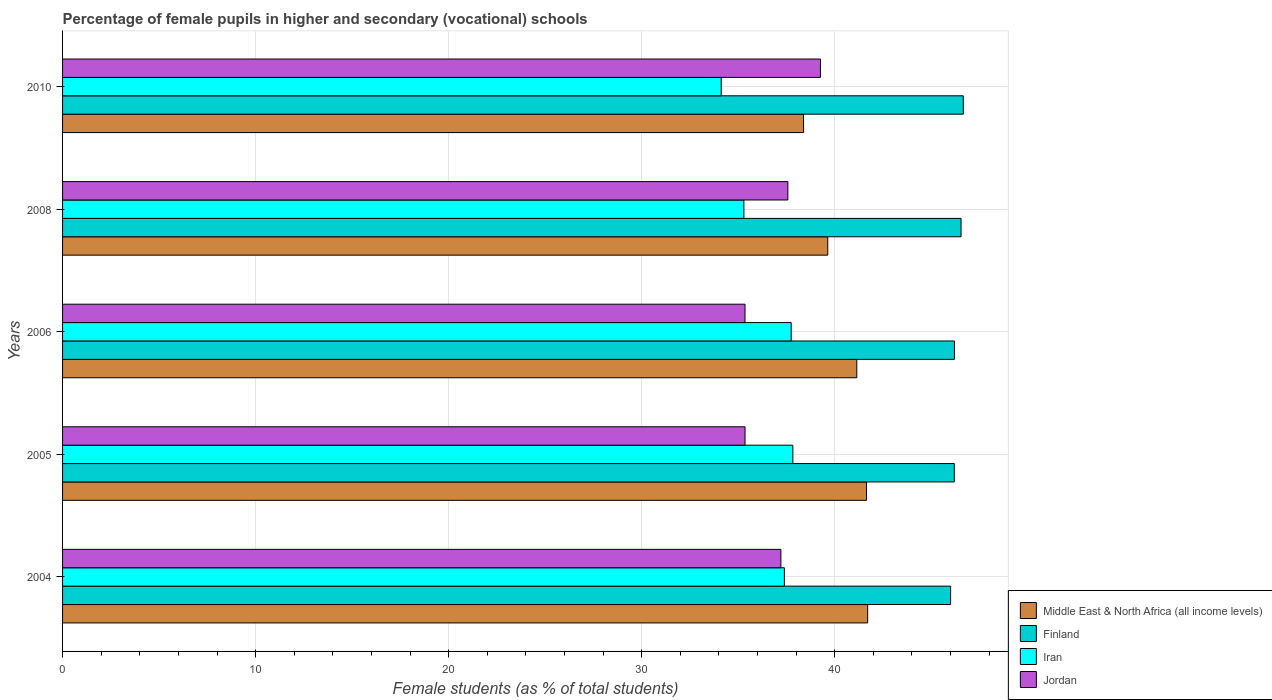How many different coloured bars are there?
Your response must be concise. 4. Are the number of bars per tick equal to the number of legend labels?
Ensure brevity in your answer.  Yes. Are the number of bars on each tick of the Y-axis equal?
Give a very brief answer. Yes. How many bars are there on the 5th tick from the top?
Your answer should be compact. 4. How many bars are there on the 4th tick from the bottom?
Ensure brevity in your answer.  4. In how many cases, is the number of bars for a given year not equal to the number of legend labels?
Make the answer very short. 0. What is the percentage of female pupils in higher and secondary schools in Iran in 2008?
Your answer should be compact. 35.3. Across all years, what is the maximum percentage of female pupils in higher and secondary schools in Finland?
Your answer should be compact. 46.66. Across all years, what is the minimum percentage of female pupils in higher and secondary schools in Middle East & North Africa (all income levels)?
Your answer should be very brief. 38.39. In which year was the percentage of female pupils in higher and secondary schools in Finland maximum?
Ensure brevity in your answer.  2010. What is the total percentage of female pupils in higher and secondary schools in Iran in the graph?
Your answer should be very brief. 182.39. What is the difference between the percentage of female pupils in higher and secondary schools in Iran in 2004 and that in 2006?
Give a very brief answer. -0.35. What is the difference between the percentage of female pupils in higher and secondary schools in Middle East & North Africa (all income levels) in 2005 and the percentage of female pupils in higher and secondary schools in Iran in 2008?
Your response must be concise. 6.35. What is the average percentage of female pupils in higher and secondary schools in Middle East & North Africa (all income levels) per year?
Your answer should be compact. 40.51. In the year 2008, what is the difference between the percentage of female pupils in higher and secondary schools in Iran and percentage of female pupils in higher and secondary schools in Jordan?
Ensure brevity in your answer.  -2.28. In how many years, is the percentage of female pupils in higher and secondary schools in Middle East & North Africa (all income levels) greater than 42 %?
Ensure brevity in your answer.  0. What is the ratio of the percentage of female pupils in higher and secondary schools in Middle East & North Africa (all income levels) in 2004 to that in 2008?
Your response must be concise. 1.05. Is the percentage of female pupils in higher and secondary schools in Jordan in 2005 less than that in 2006?
Offer a terse response. No. What is the difference between the highest and the second highest percentage of female pupils in higher and secondary schools in Jordan?
Ensure brevity in your answer.  1.69. What is the difference between the highest and the lowest percentage of female pupils in higher and secondary schools in Iran?
Provide a short and direct response. 3.71. Is it the case that in every year, the sum of the percentage of female pupils in higher and secondary schools in Middle East & North Africa (all income levels) and percentage of female pupils in higher and secondary schools in Jordan is greater than the sum of percentage of female pupils in higher and secondary schools in Iran and percentage of female pupils in higher and secondary schools in Finland?
Offer a very short reply. Yes. What does the 1st bar from the top in 2008 represents?
Ensure brevity in your answer.  Jordan. What does the 1st bar from the bottom in 2008 represents?
Your response must be concise. Middle East & North Africa (all income levels). Is it the case that in every year, the sum of the percentage of female pupils in higher and secondary schools in Finland and percentage of female pupils in higher and secondary schools in Iran is greater than the percentage of female pupils in higher and secondary schools in Jordan?
Keep it short and to the point. Yes. How many bars are there?
Ensure brevity in your answer.  20. Are all the bars in the graph horizontal?
Offer a terse response. Yes. Are the values on the major ticks of X-axis written in scientific E-notation?
Your answer should be very brief. No. Does the graph contain any zero values?
Your answer should be very brief. No. Does the graph contain grids?
Provide a succinct answer. Yes. What is the title of the graph?
Your answer should be very brief. Percentage of female pupils in higher and secondary (vocational) schools. What is the label or title of the X-axis?
Your response must be concise. Female students (as % of total students). What is the label or title of the Y-axis?
Make the answer very short. Years. What is the Female students (as % of total students) in Middle East & North Africa (all income levels) in 2004?
Your answer should be compact. 41.71. What is the Female students (as % of total students) of Finland in 2004?
Your response must be concise. 46. What is the Female students (as % of total students) of Iran in 2004?
Offer a terse response. 37.39. What is the Female students (as % of total students) in Jordan in 2004?
Make the answer very short. 37.21. What is the Female students (as % of total students) in Middle East & North Africa (all income levels) in 2005?
Provide a succinct answer. 41.65. What is the Female students (as % of total students) in Finland in 2005?
Your answer should be compact. 46.2. What is the Female students (as % of total students) of Iran in 2005?
Make the answer very short. 37.83. What is the Female students (as % of total students) in Jordan in 2005?
Provide a succinct answer. 35.35. What is the Female students (as % of total students) of Middle East & North Africa (all income levels) in 2006?
Provide a short and direct response. 41.14. What is the Female students (as % of total students) of Finland in 2006?
Your answer should be very brief. 46.2. What is the Female students (as % of total students) of Iran in 2006?
Provide a short and direct response. 37.75. What is the Female students (as % of total students) of Jordan in 2006?
Your response must be concise. 35.35. What is the Female students (as % of total students) of Middle East & North Africa (all income levels) in 2008?
Ensure brevity in your answer.  39.64. What is the Female students (as % of total students) in Finland in 2008?
Make the answer very short. 46.54. What is the Female students (as % of total students) of Iran in 2008?
Provide a short and direct response. 35.3. What is the Female students (as % of total students) in Jordan in 2008?
Your response must be concise. 37.57. What is the Female students (as % of total students) in Middle East & North Africa (all income levels) in 2010?
Your answer should be compact. 38.39. What is the Female students (as % of total students) of Finland in 2010?
Keep it short and to the point. 46.66. What is the Female students (as % of total students) of Iran in 2010?
Make the answer very short. 34.12. What is the Female students (as % of total students) in Jordan in 2010?
Your answer should be very brief. 39.26. Across all years, what is the maximum Female students (as % of total students) of Middle East & North Africa (all income levels)?
Your response must be concise. 41.71. Across all years, what is the maximum Female students (as % of total students) in Finland?
Provide a succinct answer. 46.66. Across all years, what is the maximum Female students (as % of total students) in Iran?
Give a very brief answer. 37.83. Across all years, what is the maximum Female students (as % of total students) in Jordan?
Keep it short and to the point. 39.26. Across all years, what is the minimum Female students (as % of total students) in Middle East & North Africa (all income levels)?
Make the answer very short. 38.39. Across all years, what is the minimum Female students (as % of total students) of Finland?
Give a very brief answer. 46. Across all years, what is the minimum Female students (as % of total students) of Iran?
Make the answer very short. 34.12. Across all years, what is the minimum Female students (as % of total students) of Jordan?
Offer a very short reply. 35.35. What is the total Female students (as % of total students) of Middle East & North Africa (all income levels) in the graph?
Your response must be concise. 202.53. What is the total Female students (as % of total students) of Finland in the graph?
Your response must be concise. 231.61. What is the total Female students (as % of total students) of Iran in the graph?
Your answer should be very brief. 182.39. What is the total Female students (as % of total students) of Jordan in the graph?
Give a very brief answer. 184.76. What is the difference between the Female students (as % of total students) in Middle East & North Africa (all income levels) in 2004 and that in 2005?
Your response must be concise. 0.06. What is the difference between the Female students (as % of total students) in Finland in 2004 and that in 2005?
Ensure brevity in your answer.  -0.19. What is the difference between the Female students (as % of total students) of Iran in 2004 and that in 2005?
Provide a short and direct response. -0.44. What is the difference between the Female students (as % of total students) of Jordan in 2004 and that in 2005?
Your answer should be compact. 1.86. What is the difference between the Female students (as % of total students) of Middle East & North Africa (all income levels) in 2004 and that in 2006?
Give a very brief answer. 0.56. What is the difference between the Female students (as % of total students) of Finland in 2004 and that in 2006?
Ensure brevity in your answer.  -0.2. What is the difference between the Female students (as % of total students) of Iran in 2004 and that in 2006?
Your answer should be very brief. -0.35. What is the difference between the Female students (as % of total students) in Jordan in 2004 and that in 2006?
Provide a short and direct response. 1.86. What is the difference between the Female students (as % of total students) in Middle East & North Africa (all income levels) in 2004 and that in 2008?
Your answer should be very brief. 2.07. What is the difference between the Female students (as % of total students) in Finland in 2004 and that in 2008?
Your answer should be very brief. -0.54. What is the difference between the Female students (as % of total students) in Iran in 2004 and that in 2008?
Provide a short and direct response. 2.1. What is the difference between the Female students (as % of total students) in Jordan in 2004 and that in 2008?
Offer a very short reply. -0.36. What is the difference between the Female students (as % of total students) of Middle East & North Africa (all income levels) in 2004 and that in 2010?
Offer a terse response. 3.32. What is the difference between the Female students (as % of total students) in Finland in 2004 and that in 2010?
Provide a succinct answer. -0.66. What is the difference between the Female students (as % of total students) of Iran in 2004 and that in 2010?
Your answer should be compact. 3.27. What is the difference between the Female students (as % of total students) in Jordan in 2004 and that in 2010?
Your answer should be compact. -2.05. What is the difference between the Female students (as % of total students) of Middle East & North Africa (all income levels) in 2005 and that in 2006?
Your response must be concise. 0.5. What is the difference between the Female students (as % of total students) of Finland in 2005 and that in 2006?
Your answer should be very brief. -0.01. What is the difference between the Female students (as % of total students) of Iran in 2005 and that in 2006?
Your answer should be compact. 0.09. What is the difference between the Female students (as % of total students) in Jordan in 2005 and that in 2006?
Give a very brief answer. 0. What is the difference between the Female students (as % of total students) in Middle East & North Africa (all income levels) in 2005 and that in 2008?
Keep it short and to the point. 2.01. What is the difference between the Female students (as % of total students) of Finland in 2005 and that in 2008?
Your answer should be compact. -0.35. What is the difference between the Female students (as % of total students) in Iran in 2005 and that in 2008?
Keep it short and to the point. 2.54. What is the difference between the Female students (as % of total students) of Jordan in 2005 and that in 2008?
Offer a terse response. -2.22. What is the difference between the Female students (as % of total students) in Middle East & North Africa (all income levels) in 2005 and that in 2010?
Keep it short and to the point. 3.26. What is the difference between the Female students (as % of total students) of Finland in 2005 and that in 2010?
Keep it short and to the point. -0.47. What is the difference between the Female students (as % of total students) in Iran in 2005 and that in 2010?
Give a very brief answer. 3.71. What is the difference between the Female students (as % of total students) of Jordan in 2005 and that in 2010?
Offer a terse response. -3.91. What is the difference between the Female students (as % of total students) of Middle East & North Africa (all income levels) in 2006 and that in 2008?
Your answer should be compact. 1.5. What is the difference between the Female students (as % of total students) in Finland in 2006 and that in 2008?
Your answer should be compact. -0.34. What is the difference between the Female students (as % of total students) in Iran in 2006 and that in 2008?
Keep it short and to the point. 2.45. What is the difference between the Female students (as % of total students) of Jordan in 2006 and that in 2008?
Your answer should be compact. -2.22. What is the difference between the Female students (as % of total students) in Middle East & North Africa (all income levels) in 2006 and that in 2010?
Your answer should be compact. 2.76. What is the difference between the Female students (as % of total students) in Finland in 2006 and that in 2010?
Give a very brief answer. -0.46. What is the difference between the Female students (as % of total students) in Iran in 2006 and that in 2010?
Your answer should be very brief. 3.63. What is the difference between the Female students (as % of total students) in Jordan in 2006 and that in 2010?
Give a very brief answer. -3.91. What is the difference between the Female students (as % of total students) of Middle East & North Africa (all income levels) in 2008 and that in 2010?
Offer a very short reply. 1.26. What is the difference between the Female students (as % of total students) in Finland in 2008 and that in 2010?
Your answer should be very brief. -0.12. What is the difference between the Female students (as % of total students) in Iran in 2008 and that in 2010?
Give a very brief answer. 1.17. What is the difference between the Female students (as % of total students) of Jordan in 2008 and that in 2010?
Offer a very short reply. -1.69. What is the difference between the Female students (as % of total students) of Middle East & North Africa (all income levels) in 2004 and the Female students (as % of total students) of Finland in 2005?
Provide a short and direct response. -4.49. What is the difference between the Female students (as % of total students) of Middle East & North Africa (all income levels) in 2004 and the Female students (as % of total students) of Iran in 2005?
Your answer should be very brief. 3.88. What is the difference between the Female students (as % of total students) in Middle East & North Africa (all income levels) in 2004 and the Female students (as % of total students) in Jordan in 2005?
Offer a very short reply. 6.35. What is the difference between the Female students (as % of total students) of Finland in 2004 and the Female students (as % of total students) of Iran in 2005?
Make the answer very short. 8.17. What is the difference between the Female students (as % of total students) in Finland in 2004 and the Female students (as % of total students) in Jordan in 2005?
Your answer should be compact. 10.65. What is the difference between the Female students (as % of total students) of Iran in 2004 and the Female students (as % of total students) of Jordan in 2005?
Give a very brief answer. 2.04. What is the difference between the Female students (as % of total students) in Middle East & North Africa (all income levels) in 2004 and the Female students (as % of total students) in Finland in 2006?
Provide a short and direct response. -4.5. What is the difference between the Female students (as % of total students) in Middle East & North Africa (all income levels) in 2004 and the Female students (as % of total students) in Iran in 2006?
Offer a terse response. 3.96. What is the difference between the Female students (as % of total students) in Middle East & North Africa (all income levels) in 2004 and the Female students (as % of total students) in Jordan in 2006?
Your answer should be very brief. 6.35. What is the difference between the Female students (as % of total students) in Finland in 2004 and the Female students (as % of total students) in Iran in 2006?
Give a very brief answer. 8.26. What is the difference between the Female students (as % of total students) in Finland in 2004 and the Female students (as % of total students) in Jordan in 2006?
Ensure brevity in your answer.  10.65. What is the difference between the Female students (as % of total students) in Iran in 2004 and the Female students (as % of total students) in Jordan in 2006?
Ensure brevity in your answer.  2.04. What is the difference between the Female students (as % of total students) in Middle East & North Africa (all income levels) in 2004 and the Female students (as % of total students) in Finland in 2008?
Offer a very short reply. -4.84. What is the difference between the Female students (as % of total students) in Middle East & North Africa (all income levels) in 2004 and the Female students (as % of total students) in Iran in 2008?
Your response must be concise. 6.41. What is the difference between the Female students (as % of total students) of Middle East & North Africa (all income levels) in 2004 and the Female students (as % of total students) of Jordan in 2008?
Keep it short and to the point. 4.13. What is the difference between the Female students (as % of total students) in Finland in 2004 and the Female students (as % of total students) in Iran in 2008?
Give a very brief answer. 10.71. What is the difference between the Female students (as % of total students) in Finland in 2004 and the Female students (as % of total students) in Jordan in 2008?
Make the answer very short. 8.43. What is the difference between the Female students (as % of total students) of Iran in 2004 and the Female students (as % of total students) of Jordan in 2008?
Your answer should be compact. -0.18. What is the difference between the Female students (as % of total students) of Middle East & North Africa (all income levels) in 2004 and the Female students (as % of total students) of Finland in 2010?
Provide a succinct answer. -4.95. What is the difference between the Female students (as % of total students) of Middle East & North Africa (all income levels) in 2004 and the Female students (as % of total students) of Iran in 2010?
Your answer should be compact. 7.59. What is the difference between the Female students (as % of total students) in Middle East & North Africa (all income levels) in 2004 and the Female students (as % of total students) in Jordan in 2010?
Offer a very short reply. 2.45. What is the difference between the Female students (as % of total students) in Finland in 2004 and the Female students (as % of total students) in Iran in 2010?
Keep it short and to the point. 11.88. What is the difference between the Female students (as % of total students) of Finland in 2004 and the Female students (as % of total students) of Jordan in 2010?
Provide a short and direct response. 6.74. What is the difference between the Female students (as % of total students) of Iran in 2004 and the Female students (as % of total students) of Jordan in 2010?
Offer a terse response. -1.87. What is the difference between the Female students (as % of total students) in Middle East & North Africa (all income levels) in 2005 and the Female students (as % of total students) in Finland in 2006?
Make the answer very short. -4.56. What is the difference between the Female students (as % of total students) of Middle East & North Africa (all income levels) in 2005 and the Female students (as % of total students) of Iran in 2006?
Provide a short and direct response. 3.9. What is the difference between the Female students (as % of total students) in Middle East & North Africa (all income levels) in 2005 and the Female students (as % of total students) in Jordan in 2006?
Offer a terse response. 6.29. What is the difference between the Female students (as % of total students) in Finland in 2005 and the Female students (as % of total students) in Iran in 2006?
Ensure brevity in your answer.  8.45. What is the difference between the Female students (as % of total students) of Finland in 2005 and the Female students (as % of total students) of Jordan in 2006?
Offer a terse response. 10.84. What is the difference between the Female students (as % of total students) in Iran in 2005 and the Female students (as % of total students) in Jordan in 2006?
Provide a short and direct response. 2.48. What is the difference between the Female students (as % of total students) in Middle East & North Africa (all income levels) in 2005 and the Female students (as % of total students) in Finland in 2008?
Provide a succinct answer. -4.9. What is the difference between the Female students (as % of total students) of Middle East & North Africa (all income levels) in 2005 and the Female students (as % of total students) of Iran in 2008?
Offer a terse response. 6.35. What is the difference between the Female students (as % of total students) of Middle East & North Africa (all income levels) in 2005 and the Female students (as % of total students) of Jordan in 2008?
Provide a short and direct response. 4.07. What is the difference between the Female students (as % of total students) of Finland in 2005 and the Female students (as % of total students) of Iran in 2008?
Your answer should be very brief. 10.9. What is the difference between the Female students (as % of total students) in Finland in 2005 and the Female students (as % of total students) in Jordan in 2008?
Keep it short and to the point. 8.62. What is the difference between the Female students (as % of total students) in Iran in 2005 and the Female students (as % of total students) in Jordan in 2008?
Make the answer very short. 0.26. What is the difference between the Female students (as % of total students) of Middle East & North Africa (all income levels) in 2005 and the Female students (as % of total students) of Finland in 2010?
Your answer should be very brief. -5.02. What is the difference between the Female students (as % of total students) in Middle East & North Africa (all income levels) in 2005 and the Female students (as % of total students) in Iran in 2010?
Your answer should be compact. 7.53. What is the difference between the Female students (as % of total students) of Middle East & North Africa (all income levels) in 2005 and the Female students (as % of total students) of Jordan in 2010?
Your answer should be very brief. 2.39. What is the difference between the Female students (as % of total students) in Finland in 2005 and the Female students (as % of total students) in Iran in 2010?
Keep it short and to the point. 12.07. What is the difference between the Female students (as % of total students) in Finland in 2005 and the Female students (as % of total students) in Jordan in 2010?
Offer a very short reply. 6.93. What is the difference between the Female students (as % of total students) of Iran in 2005 and the Female students (as % of total students) of Jordan in 2010?
Offer a very short reply. -1.43. What is the difference between the Female students (as % of total students) of Middle East & North Africa (all income levels) in 2006 and the Female students (as % of total students) of Finland in 2008?
Give a very brief answer. -5.4. What is the difference between the Female students (as % of total students) in Middle East & North Africa (all income levels) in 2006 and the Female students (as % of total students) in Iran in 2008?
Offer a terse response. 5.85. What is the difference between the Female students (as % of total students) of Middle East & North Africa (all income levels) in 2006 and the Female students (as % of total students) of Jordan in 2008?
Offer a terse response. 3.57. What is the difference between the Female students (as % of total students) of Finland in 2006 and the Female students (as % of total students) of Iran in 2008?
Give a very brief answer. 10.91. What is the difference between the Female students (as % of total students) in Finland in 2006 and the Female students (as % of total students) in Jordan in 2008?
Your answer should be very brief. 8.63. What is the difference between the Female students (as % of total students) in Iran in 2006 and the Female students (as % of total students) in Jordan in 2008?
Ensure brevity in your answer.  0.17. What is the difference between the Female students (as % of total students) in Middle East & North Africa (all income levels) in 2006 and the Female students (as % of total students) in Finland in 2010?
Your answer should be very brief. -5.52. What is the difference between the Female students (as % of total students) of Middle East & North Africa (all income levels) in 2006 and the Female students (as % of total students) of Iran in 2010?
Provide a short and direct response. 7.02. What is the difference between the Female students (as % of total students) of Middle East & North Africa (all income levels) in 2006 and the Female students (as % of total students) of Jordan in 2010?
Offer a terse response. 1.88. What is the difference between the Female students (as % of total students) in Finland in 2006 and the Female students (as % of total students) in Iran in 2010?
Ensure brevity in your answer.  12.08. What is the difference between the Female students (as % of total students) in Finland in 2006 and the Female students (as % of total students) in Jordan in 2010?
Keep it short and to the point. 6.94. What is the difference between the Female students (as % of total students) in Iran in 2006 and the Female students (as % of total students) in Jordan in 2010?
Your response must be concise. -1.52. What is the difference between the Female students (as % of total students) in Middle East & North Africa (all income levels) in 2008 and the Female students (as % of total students) in Finland in 2010?
Offer a very short reply. -7.02. What is the difference between the Female students (as % of total students) in Middle East & North Africa (all income levels) in 2008 and the Female students (as % of total students) in Iran in 2010?
Offer a terse response. 5.52. What is the difference between the Female students (as % of total students) in Middle East & North Africa (all income levels) in 2008 and the Female students (as % of total students) in Jordan in 2010?
Offer a very short reply. 0.38. What is the difference between the Female students (as % of total students) of Finland in 2008 and the Female students (as % of total students) of Iran in 2010?
Keep it short and to the point. 12.42. What is the difference between the Female students (as % of total students) in Finland in 2008 and the Female students (as % of total students) in Jordan in 2010?
Provide a short and direct response. 7.28. What is the difference between the Female students (as % of total students) of Iran in 2008 and the Female students (as % of total students) of Jordan in 2010?
Offer a terse response. -3.97. What is the average Female students (as % of total students) in Middle East & North Africa (all income levels) per year?
Offer a terse response. 40.51. What is the average Female students (as % of total students) in Finland per year?
Your response must be concise. 46.32. What is the average Female students (as % of total students) in Iran per year?
Make the answer very short. 36.48. What is the average Female students (as % of total students) of Jordan per year?
Offer a terse response. 36.95. In the year 2004, what is the difference between the Female students (as % of total students) in Middle East & North Africa (all income levels) and Female students (as % of total students) in Finland?
Make the answer very short. -4.3. In the year 2004, what is the difference between the Female students (as % of total students) of Middle East & North Africa (all income levels) and Female students (as % of total students) of Iran?
Your response must be concise. 4.31. In the year 2004, what is the difference between the Female students (as % of total students) of Middle East & North Africa (all income levels) and Female students (as % of total students) of Jordan?
Your answer should be very brief. 4.5. In the year 2004, what is the difference between the Female students (as % of total students) in Finland and Female students (as % of total students) in Iran?
Offer a terse response. 8.61. In the year 2004, what is the difference between the Female students (as % of total students) in Finland and Female students (as % of total students) in Jordan?
Your answer should be compact. 8.79. In the year 2004, what is the difference between the Female students (as % of total students) of Iran and Female students (as % of total students) of Jordan?
Provide a short and direct response. 0.18. In the year 2005, what is the difference between the Female students (as % of total students) of Middle East & North Africa (all income levels) and Female students (as % of total students) of Finland?
Make the answer very short. -4.55. In the year 2005, what is the difference between the Female students (as % of total students) in Middle East & North Africa (all income levels) and Female students (as % of total students) in Iran?
Your answer should be very brief. 3.82. In the year 2005, what is the difference between the Female students (as % of total students) in Middle East & North Africa (all income levels) and Female students (as % of total students) in Jordan?
Make the answer very short. 6.29. In the year 2005, what is the difference between the Female students (as % of total students) of Finland and Female students (as % of total students) of Iran?
Keep it short and to the point. 8.36. In the year 2005, what is the difference between the Female students (as % of total students) of Finland and Female students (as % of total students) of Jordan?
Your answer should be compact. 10.84. In the year 2005, what is the difference between the Female students (as % of total students) in Iran and Female students (as % of total students) in Jordan?
Your answer should be very brief. 2.48. In the year 2006, what is the difference between the Female students (as % of total students) of Middle East & North Africa (all income levels) and Female students (as % of total students) of Finland?
Keep it short and to the point. -5.06. In the year 2006, what is the difference between the Female students (as % of total students) of Middle East & North Africa (all income levels) and Female students (as % of total students) of Iran?
Ensure brevity in your answer.  3.4. In the year 2006, what is the difference between the Female students (as % of total students) in Middle East & North Africa (all income levels) and Female students (as % of total students) in Jordan?
Your response must be concise. 5.79. In the year 2006, what is the difference between the Female students (as % of total students) of Finland and Female students (as % of total students) of Iran?
Offer a very short reply. 8.46. In the year 2006, what is the difference between the Female students (as % of total students) of Finland and Female students (as % of total students) of Jordan?
Your answer should be very brief. 10.85. In the year 2006, what is the difference between the Female students (as % of total students) in Iran and Female students (as % of total students) in Jordan?
Your answer should be very brief. 2.39. In the year 2008, what is the difference between the Female students (as % of total students) in Middle East & North Africa (all income levels) and Female students (as % of total students) in Finland?
Your response must be concise. -6.9. In the year 2008, what is the difference between the Female students (as % of total students) of Middle East & North Africa (all income levels) and Female students (as % of total students) of Iran?
Offer a very short reply. 4.35. In the year 2008, what is the difference between the Female students (as % of total students) of Middle East & North Africa (all income levels) and Female students (as % of total students) of Jordan?
Your answer should be very brief. 2.07. In the year 2008, what is the difference between the Female students (as % of total students) of Finland and Female students (as % of total students) of Iran?
Offer a terse response. 11.25. In the year 2008, what is the difference between the Female students (as % of total students) of Finland and Female students (as % of total students) of Jordan?
Offer a terse response. 8.97. In the year 2008, what is the difference between the Female students (as % of total students) in Iran and Female students (as % of total students) in Jordan?
Offer a terse response. -2.28. In the year 2010, what is the difference between the Female students (as % of total students) of Middle East & North Africa (all income levels) and Female students (as % of total students) of Finland?
Your answer should be very brief. -8.28. In the year 2010, what is the difference between the Female students (as % of total students) of Middle East & North Africa (all income levels) and Female students (as % of total students) of Iran?
Give a very brief answer. 4.26. In the year 2010, what is the difference between the Female students (as % of total students) of Middle East & North Africa (all income levels) and Female students (as % of total students) of Jordan?
Your answer should be compact. -0.88. In the year 2010, what is the difference between the Female students (as % of total students) in Finland and Female students (as % of total students) in Iran?
Keep it short and to the point. 12.54. In the year 2010, what is the difference between the Female students (as % of total students) in Finland and Female students (as % of total students) in Jordan?
Ensure brevity in your answer.  7.4. In the year 2010, what is the difference between the Female students (as % of total students) in Iran and Female students (as % of total students) in Jordan?
Provide a short and direct response. -5.14. What is the ratio of the Female students (as % of total students) in Finland in 2004 to that in 2005?
Your response must be concise. 1. What is the ratio of the Female students (as % of total students) in Iran in 2004 to that in 2005?
Provide a short and direct response. 0.99. What is the ratio of the Female students (as % of total students) of Jordan in 2004 to that in 2005?
Make the answer very short. 1.05. What is the ratio of the Female students (as % of total students) of Middle East & North Africa (all income levels) in 2004 to that in 2006?
Your answer should be very brief. 1.01. What is the ratio of the Female students (as % of total students) in Iran in 2004 to that in 2006?
Ensure brevity in your answer.  0.99. What is the ratio of the Female students (as % of total students) of Jordan in 2004 to that in 2006?
Your answer should be compact. 1.05. What is the ratio of the Female students (as % of total students) of Middle East & North Africa (all income levels) in 2004 to that in 2008?
Offer a very short reply. 1.05. What is the ratio of the Female students (as % of total students) in Finland in 2004 to that in 2008?
Ensure brevity in your answer.  0.99. What is the ratio of the Female students (as % of total students) in Iran in 2004 to that in 2008?
Your response must be concise. 1.06. What is the ratio of the Female students (as % of total students) in Middle East & North Africa (all income levels) in 2004 to that in 2010?
Ensure brevity in your answer.  1.09. What is the ratio of the Female students (as % of total students) in Finland in 2004 to that in 2010?
Your answer should be compact. 0.99. What is the ratio of the Female students (as % of total students) in Iran in 2004 to that in 2010?
Offer a very short reply. 1.1. What is the ratio of the Female students (as % of total students) in Jordan in 2004 to that in 2010?
Provide a succinct answer. 0.95. What is the ratio of the Female students (as % of total students) in Middle East & North Africa (all income levels) in 2005 to that in 2006?
Your response must be concise. 1.01. What is the ratio of the Female students (as % of total students) in Finland in 2005 to that in 2006?
Your answer should be very brief. 1. What is the ratio of the Female students (as % of total students) in Jordan in 2005 to that in 2006?
Keep it short and to the point. 1. What is the ratio of the Female students (as % of total students) of Middle East & North Africa (all income levels) in 2005 to that in 2008?
Your answer should be very brief. 1.05. What is the ratio of the Female students (as % of total students) of Iran in 2005 to that in 2008?
Offer a terse response. 1.07. What is the ratio of the Female students (as % of total students) of Jordan in 2005 to that in 2008?
Give a very brief answer. 0.94. What is the ratio of the Female students (as % of total students) in Middle East & North Africa (all income levels) in 2005 to that in 2010?
Give a very brief answer. 1.08. What is the ratio of the Female students (as % of total students) in Iran in 2005 to that in 2010?
Your answer should be compact. 1.11. What is the ratio of the Female students (as % of total students) of Jordan in 2005 to that in 2010?
Your answer should be compact. 0.9. What is the ratio of the Female students (as % of total students) of Middle East & North Africa (all income levels) in 2006 to that in 2008?
Your answer should be compact. 1.04. What is the ratio of the Female students (as % of total students) of Iran in 2006 to that in 2008?
Keep it short and to the point. 1.07. What is the ratio of the Female students (as % of total students) of Jordan in 2006 to that in 2008?
Keep it short and to the point. 0.94. What is the ratio of the Female students (as % of total students) in Middle East & North Africa (all income levels) in 2006 to that in 2010?
Ensure brevity in your answer.  1.07. What is the ratio of the Female students (as % of total students) in Finland in 2006 to that in 2010?
Your answer should be very brief. 0.99. What is the ratio of the Female students (as % of total students) of Iran in 2006 to that in 2010?
Your answer should be compact. 1.11. What is the ratio of the Female students (as % of total students) of Jordan in 2006 to that in 2010?
Provide a short and direct response. 0.9. What is the ratio of the Female students (as % of total students) of Middle East & North Africa (all income levels) in 2008 to that in 2010?
Ensure brevity in your answer.  1.03. What is the ratio of the Female students (as % of total students) of Iran in 2008 to that in 2010?
Give a very brief answer. 1.03. What is the ratio of the Female students (as % of total students) in Jordan in 2008 to that in 2010?
Your answer should be compact. 0.96. What is the difference between the highest and the second highest Female students (as % of total students) in Middle East & North Africa (all income levels)?
Keep it short and to the point. 0.06. What is the difference between the highest and the second highest Female students (as % of total students) of Finland?
Your response must be concise. 0.12. What is the difference between the highest and the second highest Female students (as % of total students) of Iran?
Keep it short and to the point. 0.09. What is the difference between the highest and the second highest Female students (as % of total students) of Jordan?
Keep it short and to the point. 1.69. What is the difference between the highest and the lowest Female students (as % of total students) in Middle East & North Africa (all income levels)?
Make the answer very short. 3.32. What is the difference between the highest and the lowest Female students (as % of total students) of Finland?
Your response must be concise. 0.66. What is the difference between the highest and the lowest Female students (as % of total students) in Iran?
Make the answer very short. 3.71. What is the difference between the highest and the lowest Female students (as % of total students) of Jordan?
Your response must be concise. 3.91. 